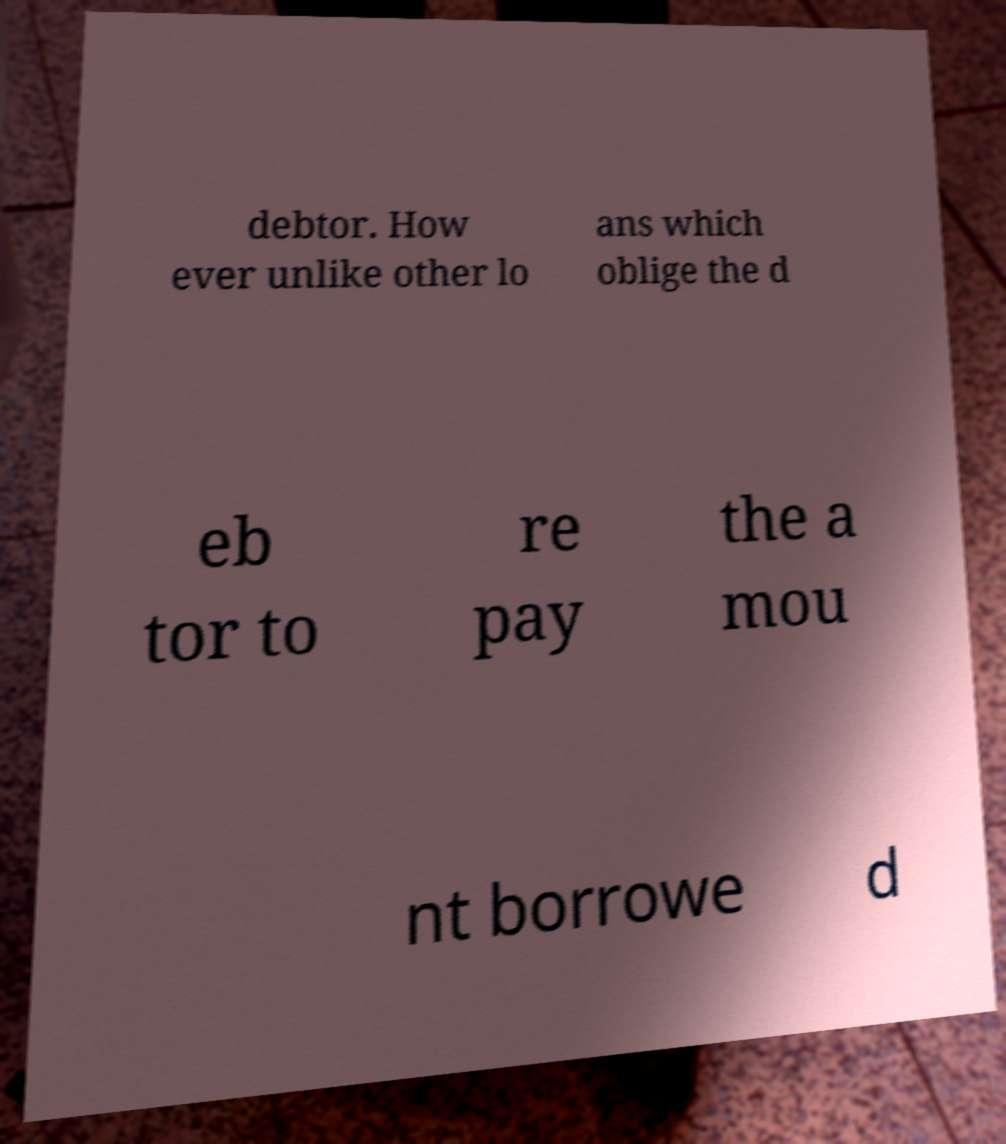For documentation purposes, I need the text within this image transcribed. Could you provide that? debtor. How ever unlike other lo ans which oblige the d eb tor to re pay the a mou nt borrowe d 